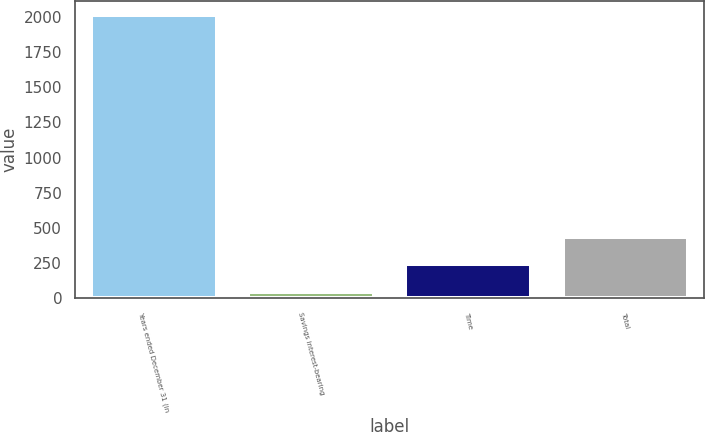Convert chart to OTSL. <chart><loc_0><loc_0><loc_500><loc_500><bar_chart><fcel>Years ended December 31 (in<fcel>Savings interest-bearing<fcel>Time<fcel>Total<nl><fcel>2015<fcel>43.5<fcel>240.65<fcel>437.8<nl></chart> 